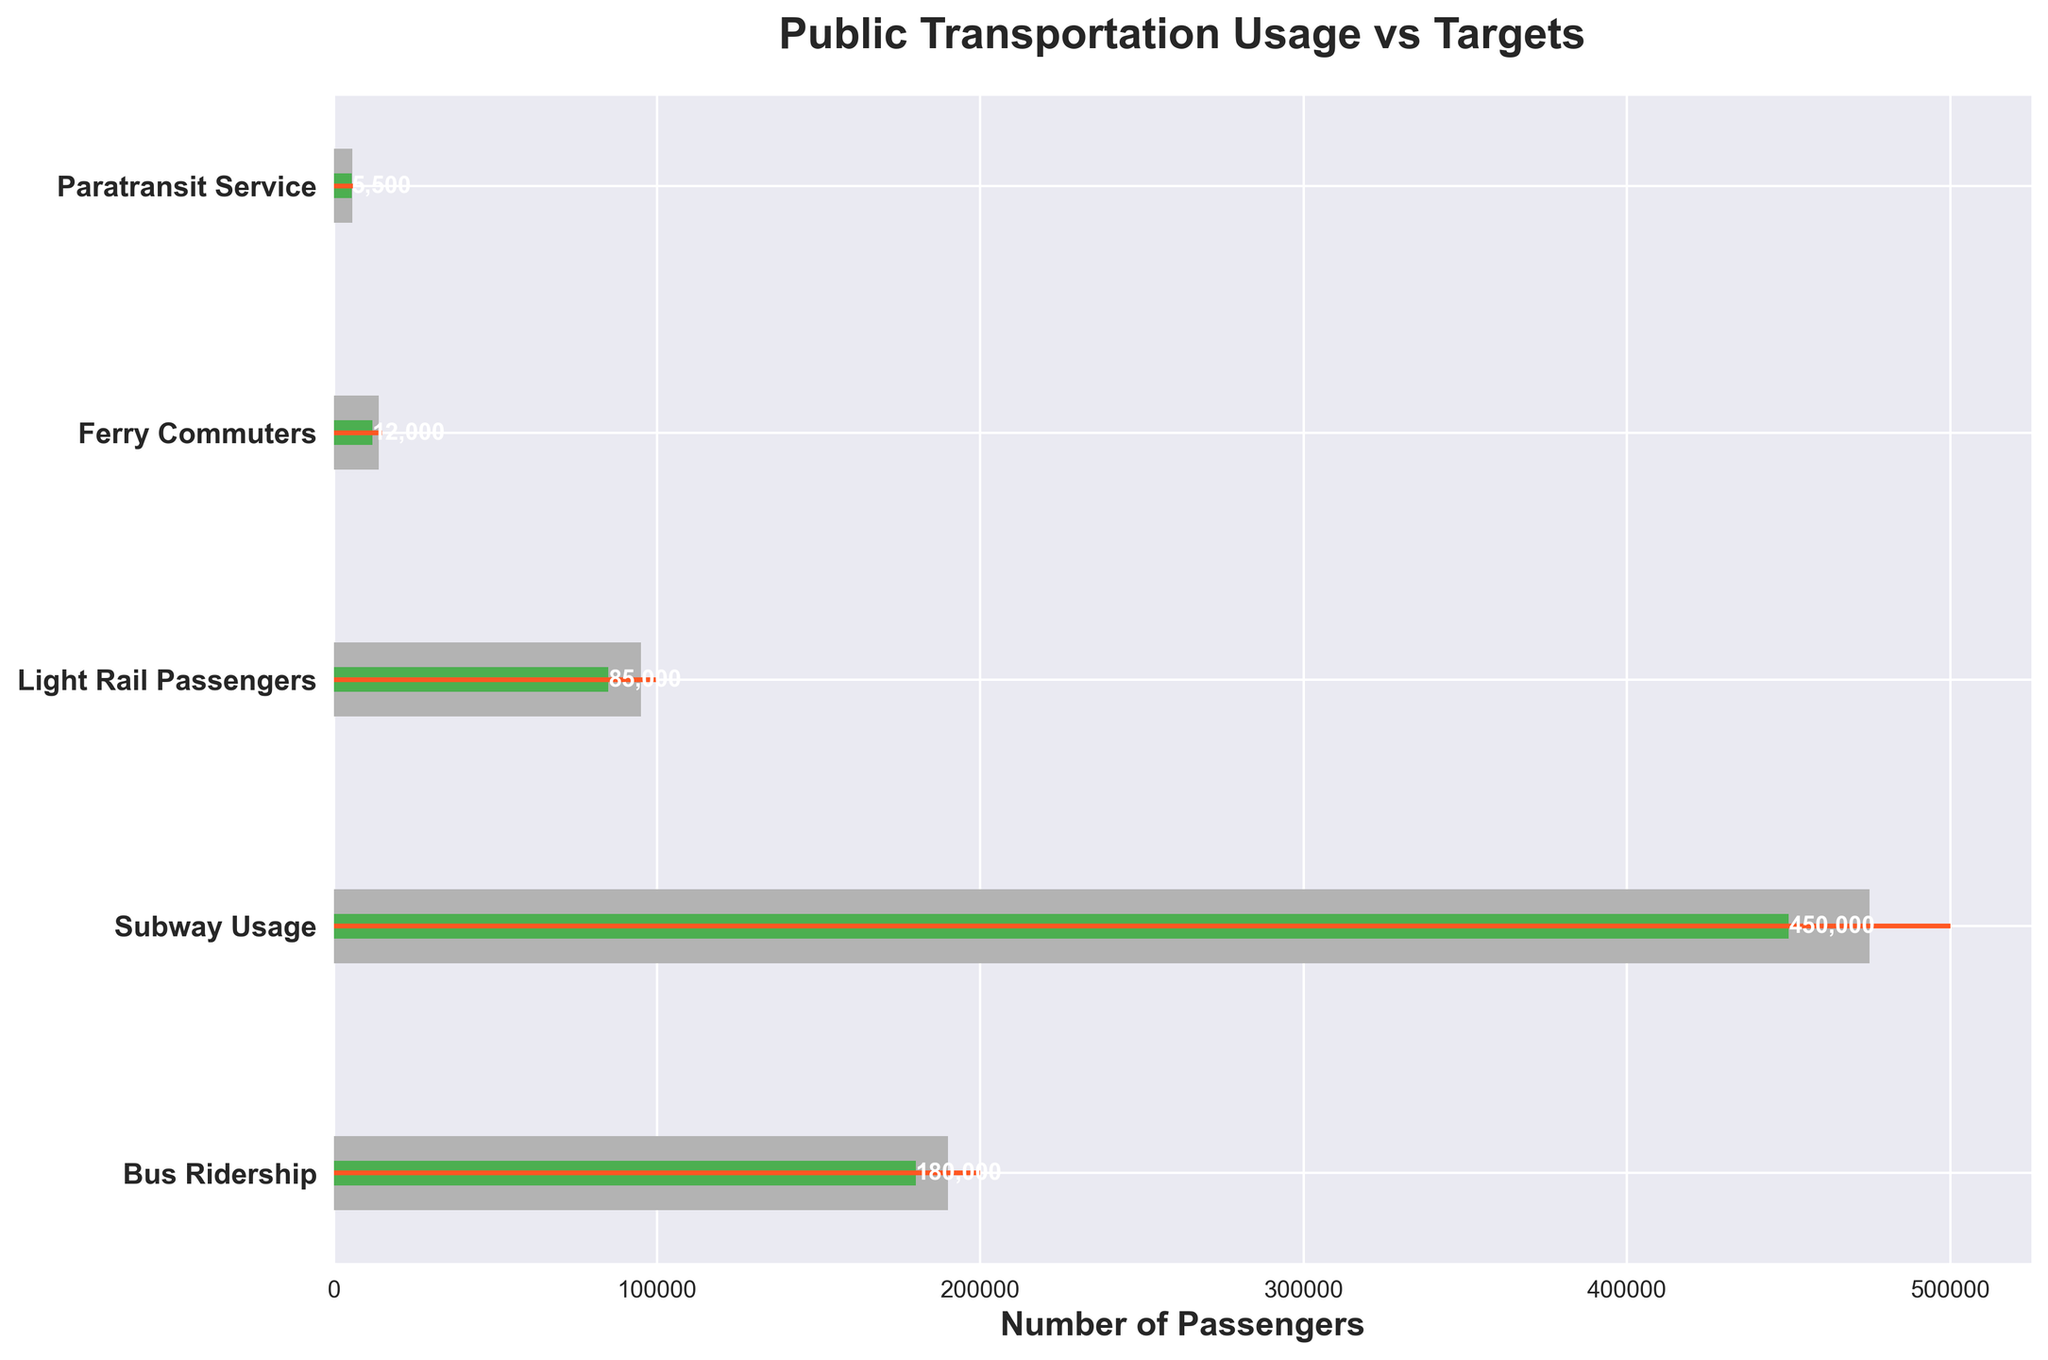What is the title of the figure? The title of the figure is written at the top.
Answer: Public Transportation Usage vs Targets How many types of public transportation are shown? Count the number of categories listed on the y-axis.
Answer: 5 Which transportation type has the highest target ridership? Compare the target values for each transportation type.
Answer: Subway Usage Is the actual ridership for any transportation type higher than its target? Compare the actual ridership with the target ridership for each transportation type.
Answer: No What transportation type is closest to meeting its target? Calculate the difference between actual and target for each type; the smallest difference is the closest.
Answer: Light Rail Passengers What is the difference in actual ridership between Bus Ridership and Ferry Commuters? Subtract the actual ridership of Ferry Commuters from that of Bus Ridership (180,000 - 12,000).
Answer: 168,000 Which transportation type has the smallest difference between actual ridership and Range3? Calculate the difference between actual ridership and Range3 for each transport type; the smallest difference is identified.
Answer: Subway Usage How does Ferry Commuters' actual ridership compare with its Range2 value? Compare the actual ridership of Ferry Commuters (12,000) with its Range2 value (11,000).
Answer: Higher Which transportation type is the furthest from meeting its target? Calculate the difference between the actual values and the targets and find the largest difference.
Answer: Ferry Commuters Is the Bus Ridership above or below Range3 value? Compare the actual Bus Ridership (180,000) to its Range3 value (190,000).
Answer: Below 